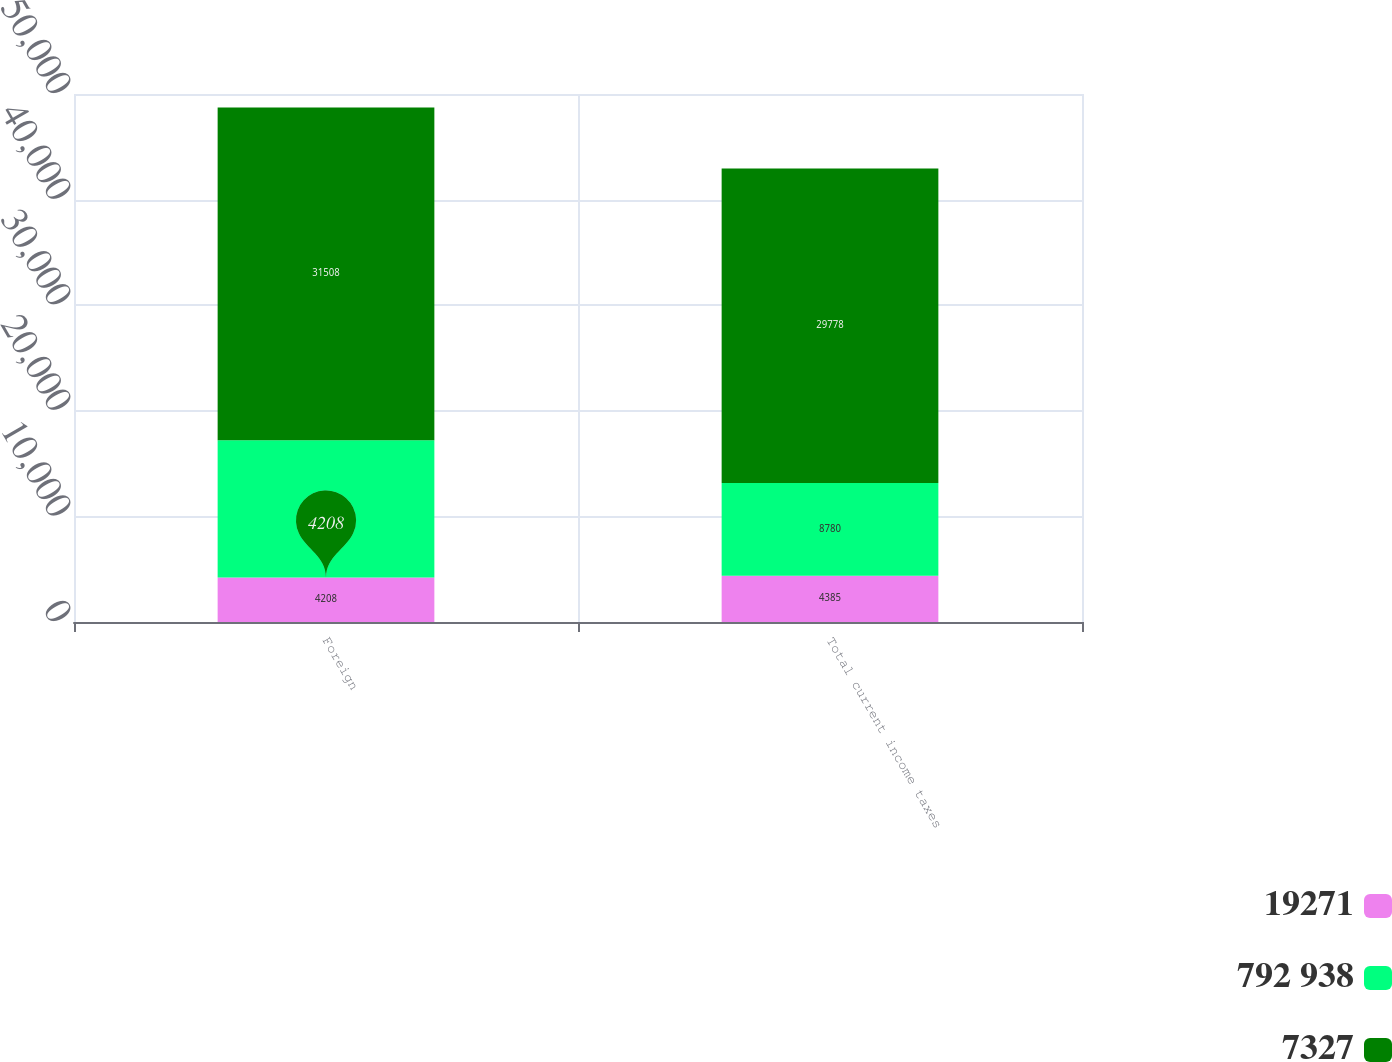Convert chart to OTSL. <chart><loc_0><loc_0><loc_500><loc_500><stacked_bar_chart><ecel><fcel>Foreign<fcel>Total current income taxes<nl><fcel>19271<fcel>4208<fcel>4385<nl><fcel>792 938<fcel>13012<fcel>8780<nl><fcel>7327<fcel>31508<fcel>29778<nl></chart> 